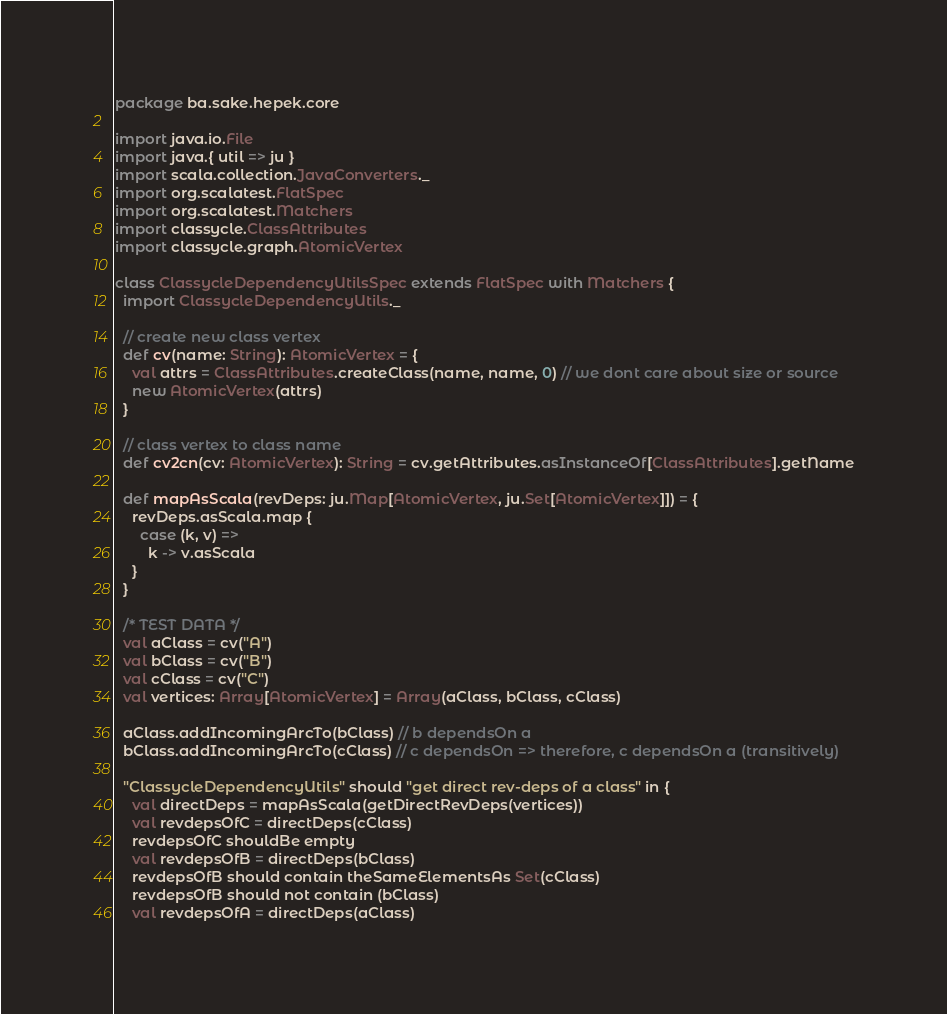Convert code to text. <code><loc_0><loc_0><loc_500><loc_500><_Scala_>package ba.sake.hepek.core

import java.io.File
import java.{ util => ju }
import scala.collection.JavaConverters._
import org.scalatest.FlatSpec
import org.scalatest.Matchers
import classycle.ClassAttributes
import classycle.graph.AtomicVertex

class ClassycleDependencyUtilsSpec extends FlatSpec with Matchers {
  import ClassycleDependencyUtils._

  // create new class vertex
  def cv(name: String): AtomicVertex = {
    val attrs = ClassAttributes.createClass(name, name, 0) // we dont care about size or source
    new AtomicVertex(attrs)
  }

  // class vertex to class name
  def cv2cn(cv: AtomicVertex): String = cv.getAttributes.asInstanceOf[ClassAttributes].getName

  def mapAsScala(revDeps: ju.Map[AtomicVertex, ju.Set[AtomicVertex]]) = {
    revDeps.asScala.map {
      case (k, v) =>
        k -> v.asScala
    }
  }

  /* TEST DATA */
  val aClass = cv("A")
  val bClass = cv("B")
  val cClass = cv("C")
  val vertices: Array[AtomicVertex] = Array(aClass, bClass, cClass)

  aClass.addIncomingArcTo(bClass) // b dependsOn a
  bClass.addIncomingArcTo(cClass) // c dependsOn => therefore, c dependsOn a (transitively)

  "ClassycleDependencyUtils" should "get direct rev-deps of a class" in {
    val directDeps = mapAsScala(getDirectRevDeps(vertices))
    val revdepsOfC = directDeps(cClass)
    revdepsOfC shouldBe empty
    val revdepsOfB = directDeps(bClass)
    revdepsOfB should contain theSameElementsAs Set(cClass)
    revdepsOfB should not contain (bClass)
    val revdepsOfA = directDeps(aClass)</code> 